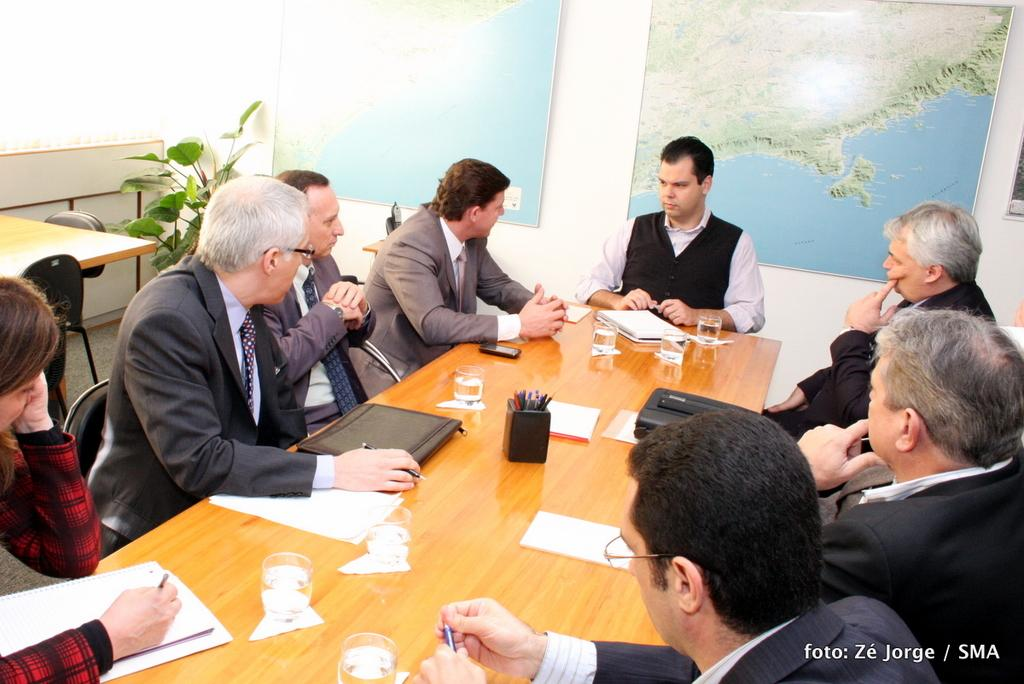What is the main piece of furniture in the image? There is a table in the image. What items can be seen on the table? There are pens, paper, a glass, and a phone on the table. What are the people sitting around the table doing? The people are sitting around the table and holding pens. What can be seen in the background of the image? There is a map, a flower, and chairs in the background of the image. How many tomatoes are on the table in the image? There are no tomatoes present on the table in the image. What type of rail is visible in the background of the image? There is no rail visible in the background of the image. 